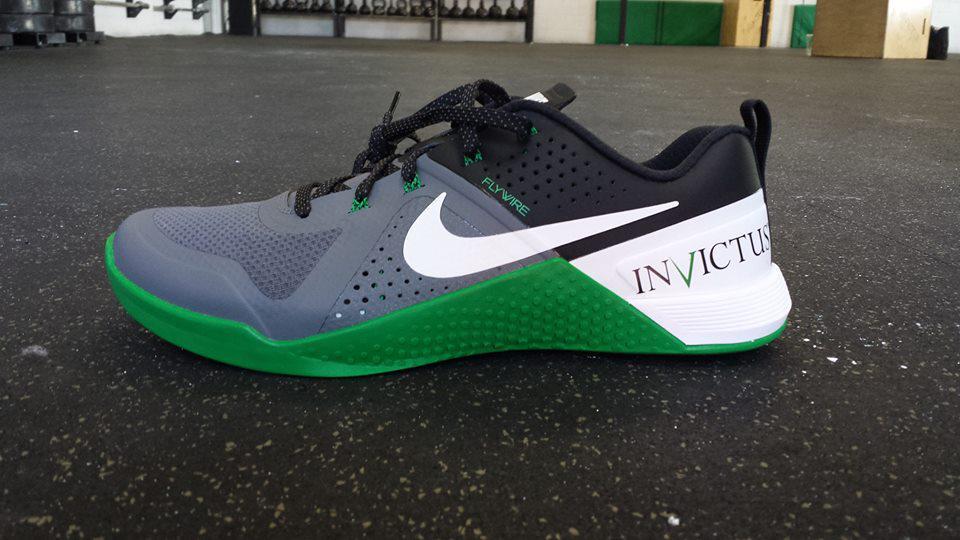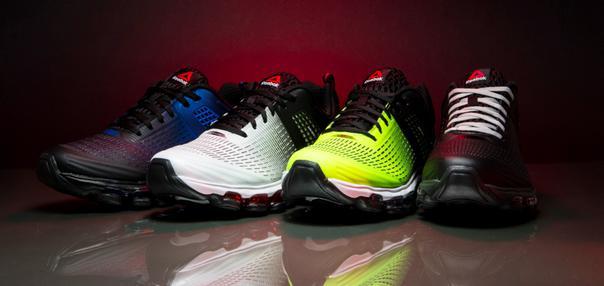The first image is the image on the left, the second image is the image on the right. Analyze the images presented: Is the assertion "Three or more of the shoes are at least partially green." valid? Answer yes or no. No. 